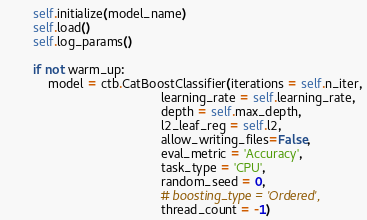Convert code to text. <code><loc_0><loc_0><loc_500><loc_500><_Python_>
        self.initialize(model_name)
        self.load()
        self.log_params()

        if not warm_up:
            model = ctb.CatBoostClassifier(iterations = self.n_iter,
                                            learning_rate = self.learning_rate,
                                            depth = self.max_depth,
                                            l2_leaf_reg = self.l2,
                                            allow_writing_files=False,
                                            eval_metric = 'Accuracy',
                                            task_type = 'CPU',
                                            random_seed = 0,
                                            # boosting_type = 'Ordered',
                                            thread_count = -1)
</code> 